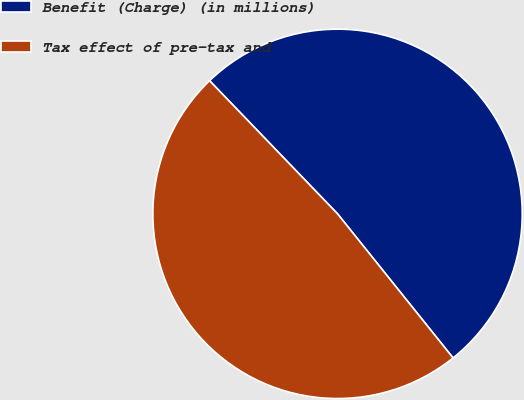Convert chart. <chart><loc_0><loc_0><loc_500><loc_500><pie_chart><fcel>Benefit (Charge) (in millions)<fcel>Tax effect of pre-tax and<nl><fcel>51.43%<fcel>48.57%<nl></chart> 